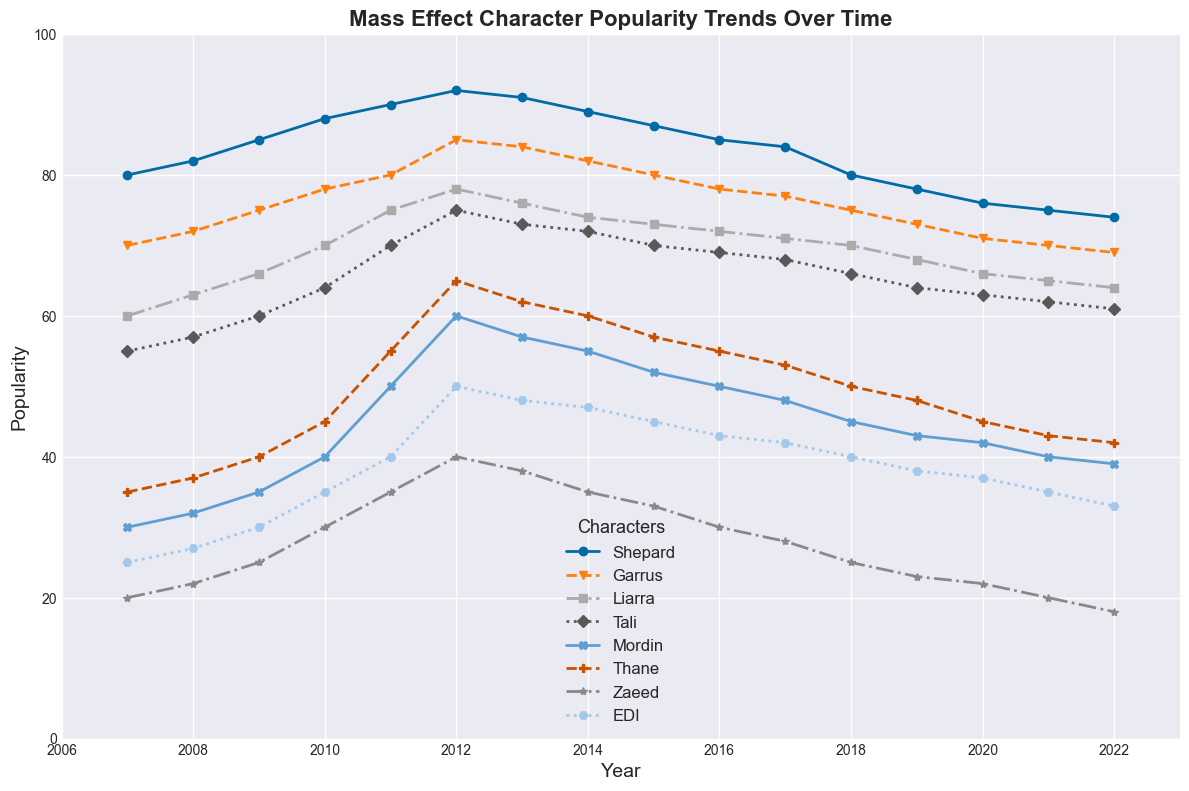what are the popularity trends of Shepard and Tali from 2007 to 2022? Shepard’s popularity increases from 80 in 2007 to 92 in 2012, peaking in 2012, and then gently declines to 74 in 2022. Tali’s popularity also shows a rising trend from 55 in 2007 to 75 in 2012 and then gradually decreases to 61 in 2022
Answer: Shepard: Peak in 2012, Tali: Peak in 2012 which character had the highest popularity in 2018? From the figure, the highest line in 2018 corresponds to Shepard, making Shepard the most popular character in that year with a popularity score of 80
Answer: Shepard who experienced the most significant decline in popularity from their peak to 2022? Mordin's popularity peaks at 60 in 2012 and drops significantly to 39 by 2022, a decline of 21 points, which is the steepest drop among all the characters
Answer: Mordin which character surpassed Shepard in popularity after 2012? Did this trend continue up to 2022? None of the characters surpassed Shepard in popularity after 2012. Shepard maintained the highest popularity score throughout the entire period from 2007 to 2022
Answer: None how did the popularity of Garrus and Thane compare in 2010? In 2010, Garrus had a popularity score of 78, while Thane had 45. Garrus was thus significantly more popular than Thane in that year
Answer: Garrus had higher popularity what is the average popularity of EDI from 2007 to 2022? To find the average, add the popularity scores of EDI for all the years and divide by the total number of years: (25 + 27 + 30 + 35 + 40 + 50 + 48 + 47 + 45 + 43 + 42 + 40 + 38 + 37 + 35 + 33) / 16 = 38.75
Answer: 38.75 in which year did Mordin experience the peak in popularity? What was the popularity score? Mordin experienced his peak in popularity in 2012 with a score of 60. This can be observed as the highest point on Mordin's trend line on the figure
Answer: Peak in 2012 with a score of 60 do Garrus and Liarra have similar popularity trends? Both characters show a generally increasing trend from 2007 to 2012 and a decreasing trend thereafter. However, Garrus has consistently higher popularity than Liarra in every year, indicating similar trends but different popularity levels
Answer: Similar trends but Garrus has higher popularity 